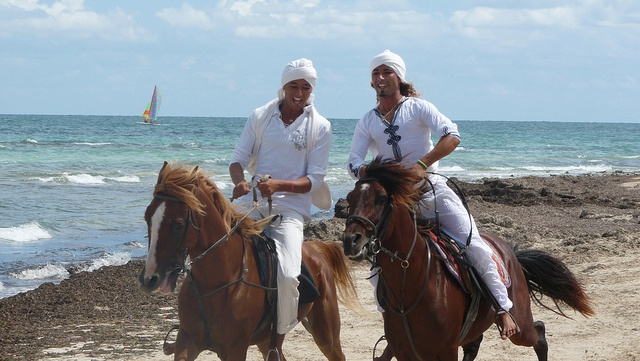Describe the objects in this image and their specific colors. I can see horse in lightblue, black, maroon, and gray tones, horse in lightblue, black, maroon, and gray tones, people in lightblue, darkgray, lavender, gray, and black tones, people in lightblue, darkgray, lightgray, gray, and maroon tones, and boat in lightgray, gray, lightblue, darkgray, and violet tones in this image. 